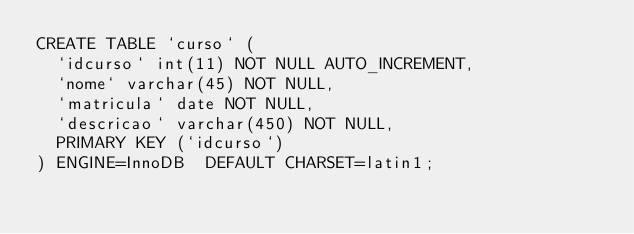<code> <loc_0><loc_0><loc_500><loc_500><_SQL_>CREATE TABLE `curso` (
  `idcurso` int(11) NOT NULL AUTO_INCREMENT,
  `nome` varchar(45) NOT NULL,
  `matricula` date NOT NULL,
  `descricao` varchar(450) NOT NULL,
  PRIMARY KEY (`idcurso`)
) ENGINE=InnoDB  DEFAULT CHARSET=latin1;
</code> 